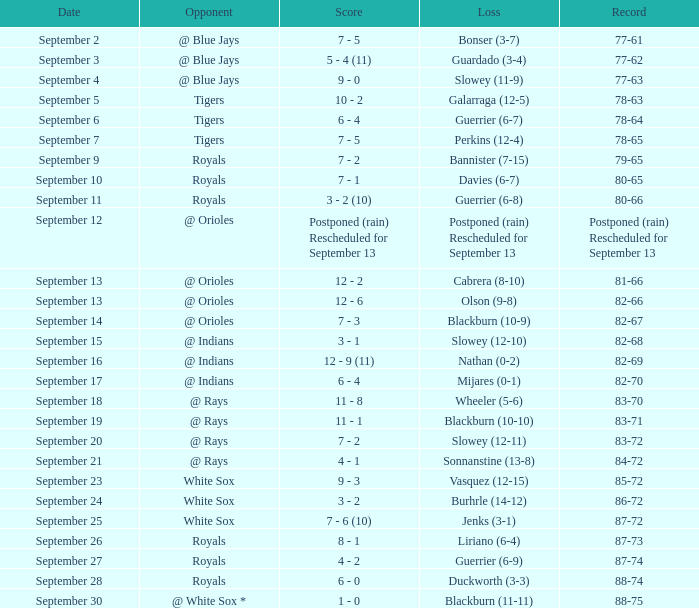What date has the record of 77-62? September 3. 